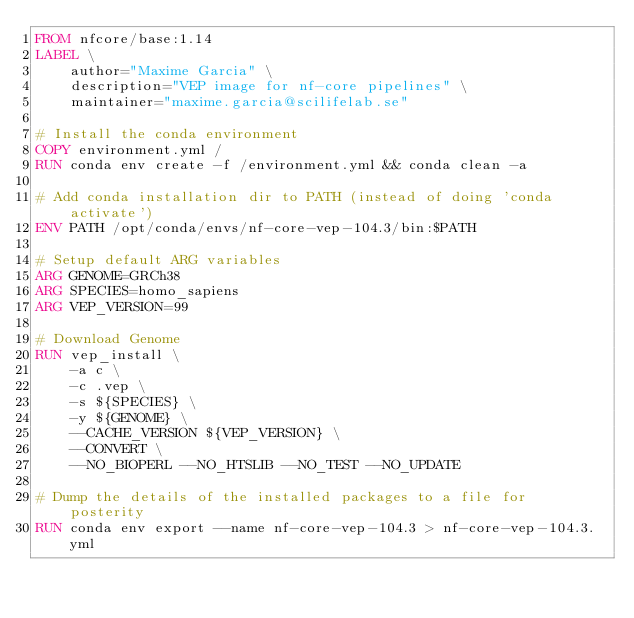Convert code to text. <code><loc_0><loc_0><loc_500><loc_500><_Dockerfile_>FROM nfcore/base:1.14
LABEL \
    author="Maxime Garcia" \
    description="VEP image for nf-core pipelines" \
    maintainer="maxime.garcia@scilifelab.se"

# Install the conda environment
COPY environment.yml /
RUN conda env create -f /environment.yml && conda clean -a

# Add conda installation dir to PATH (instead of doing 'conda activate')
ENV PATH /opt/conda/envs/nf-core-vep-104.3/bin:$PATH

# Setup default ARG variables
ARG GENOME=GRCh38
ARG SPECIES=homo_sapiens
ARG VEP_VERSION=99

# Download Genome
RUN vep_install \
    -a c \
    -c .vep \
    -s ${SPECIES} \
    -y ${GENOME} \
    --CACHE_VERSION ${VEP_VERSION} \
    --CONVERT \
    --NO_BIOPERL --NO_HTSLIB --NO_TEST --NO_UPDATE

# Dump the details of the installed packages to a file for posterity
RUN conda env export --name nf-core-vep-104.3 > nf-core-vep-104.3.yml
</code> 